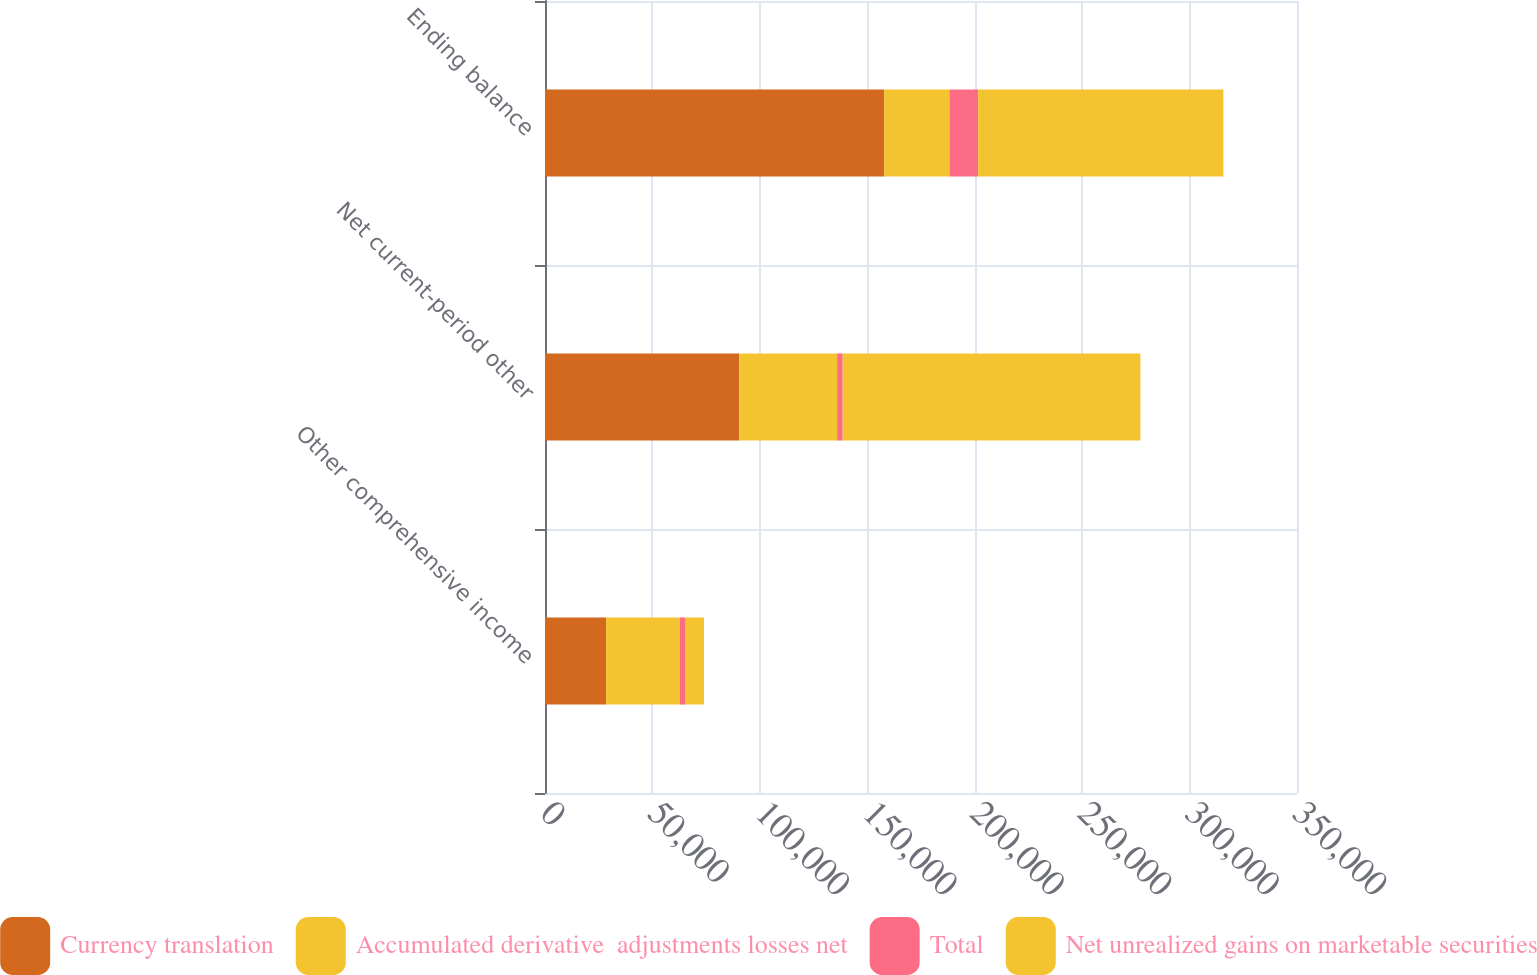Convert chart to OTSL. <chart><loc_0><loc_0><loc_500><loc_500><stacked_bar_chart><ecel><fcel>Other comprehensive income<fcel>Net current-period other<fcel>Ending balance<nl><fcel>Currency translation<fcel>28437<fcel>90421<fcel>157864<nl><fcel>Accumulated derivative  adjustments losses net<fcel>34400<fcel>45535<fcel>30374<nl><fcel>Total<fcel>2604<fcel>2604<fcel>13364<nl><fcel>Net unrealized gains on marketable securities<fcel>8567<fcel>138560<fcel>114126<nl></chart> 